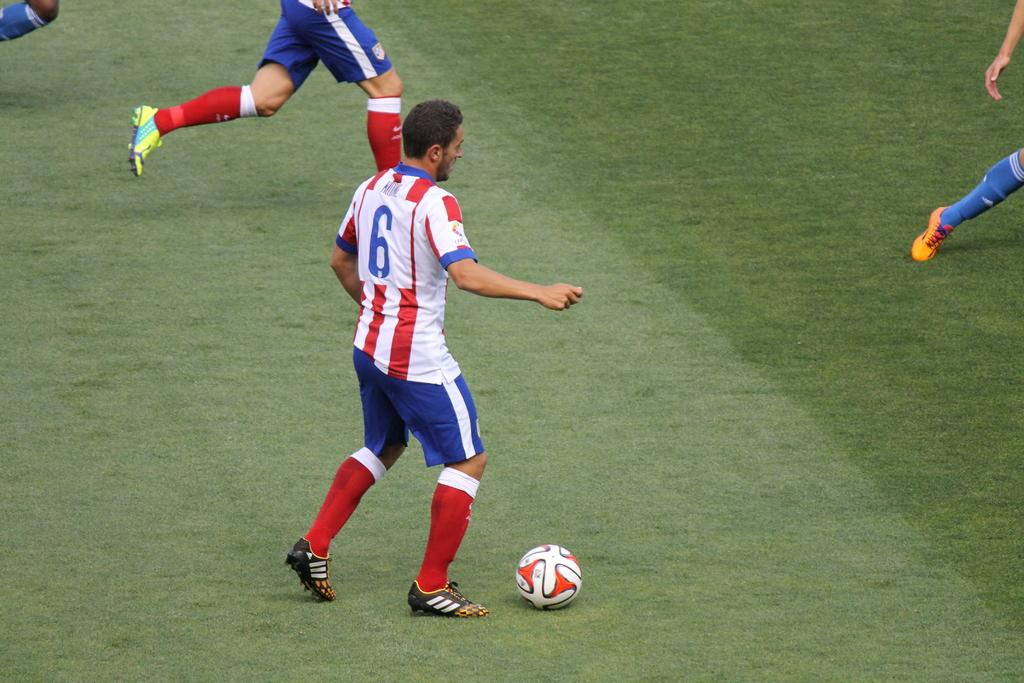Provide a one-sentence caption for the provided image. Number six gets ready to pass the ball to a teammate. 